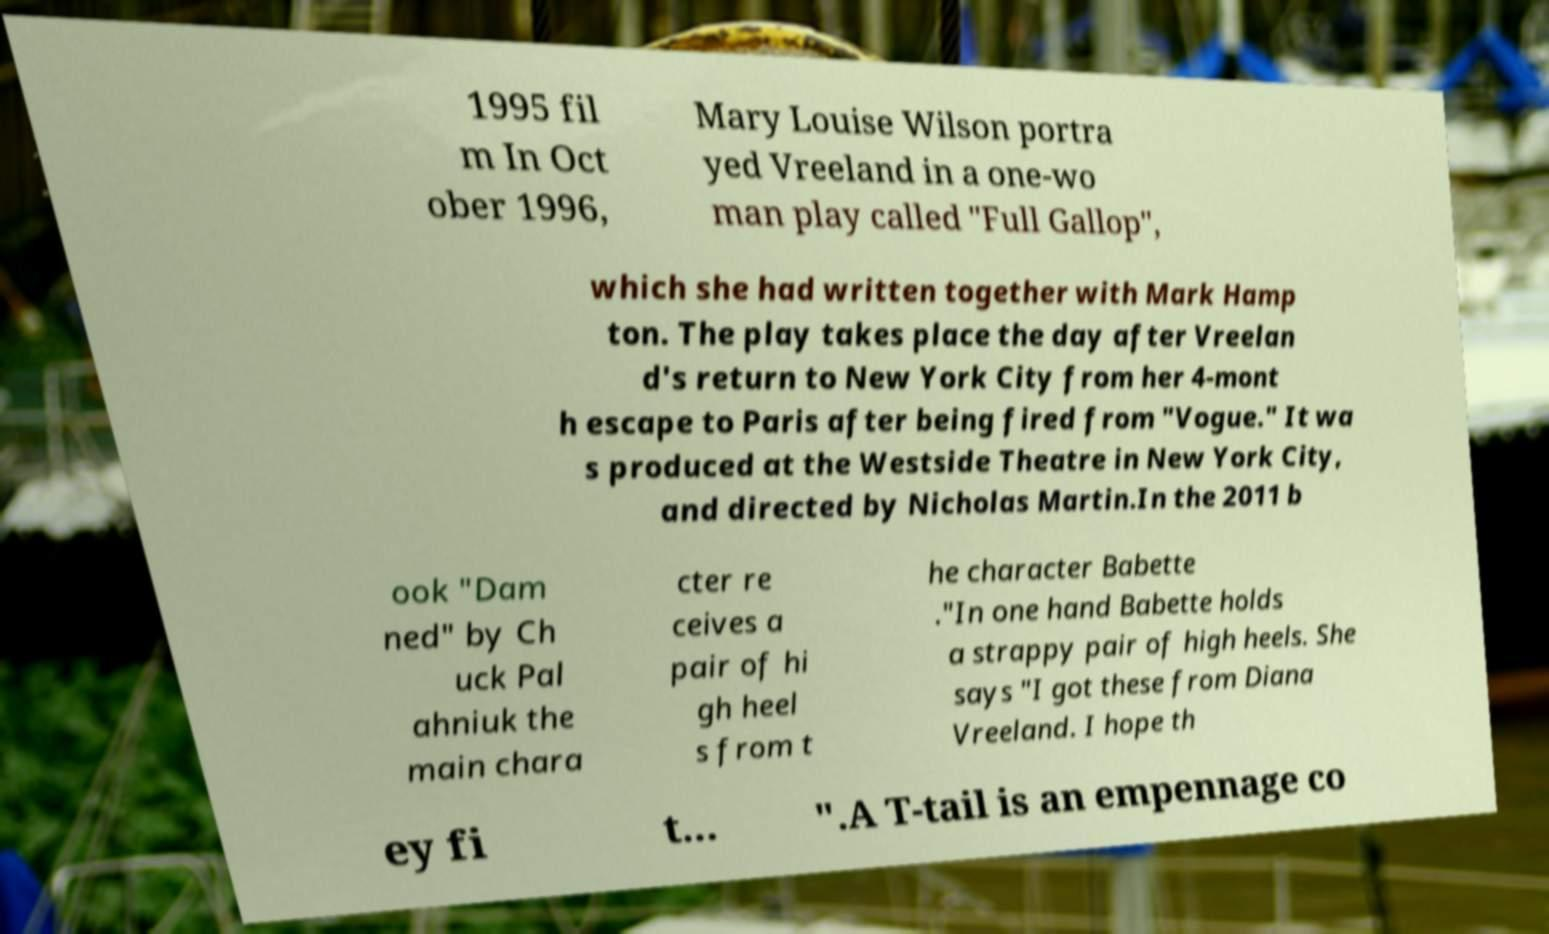What messages or text are displayed in this image? I need them in a readable, typed format. 1995 fil m In Oct ober 1996, Mary Louise Wilson portra yed Vreeland in a one-wo man play called "Full Gallop", which she had written together with Mark Hamp ton. The play takes place the day after Vreelan d's return to New York City from her 4-mont h escape to Paris after being fired from "Vogue." It wa s produced at the Westside Theatre in New York City, and directed by Nicholas Martin.In the 2011 b ook "Dam ned" by Ch uck Pal ahniuk the main chara cter re ceives a pair of hi gh heel s from t he character Babette ."In one hand Babette holds a strappy pair of high heels. She says "I got these from Diana Vreeland. I hope th ey fi t... ".A T-tail is an empennage co 